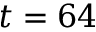Convert formula to latex. <formula><loc_0><loc_0><loc_500><loc_500>t = 6 4</formula> 